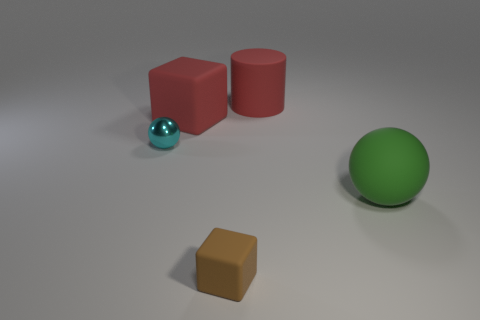Is the brown block made of the same material as the ball behind the large green matte ball?
Offer a terse response. No. How many rubber objects are tiny cubes or green objects?
Your answer should be compact. 2. There is a red matte thing that is left of the small brown thing; what size is it?
Provide a succinct answer. Large. What size is the ball that is made of the same material as the big red block?
Offer a very short reply. Large. What number of other large matte cylinders have the same color as the large rubber cylinder?
Your answer should be compact. 0. Are any small brown metallic balls visible?
Your response must be concise. No. Is the shape of the brown rubber thing the same as the green matte object behind the brown block?
Provide a short and direct response. No. There is a block to the right of the block behind the large rubber thing on the right side of the big cylinder; what color is it?
Offer a terse response. Brown. There is a tiny cyan metal object; are there any rubber things behind it?
Offer a terse response. Yes. What size is the matte cylinder that is the same color as the large matte cube?
Provide a short and direct response. Large. 